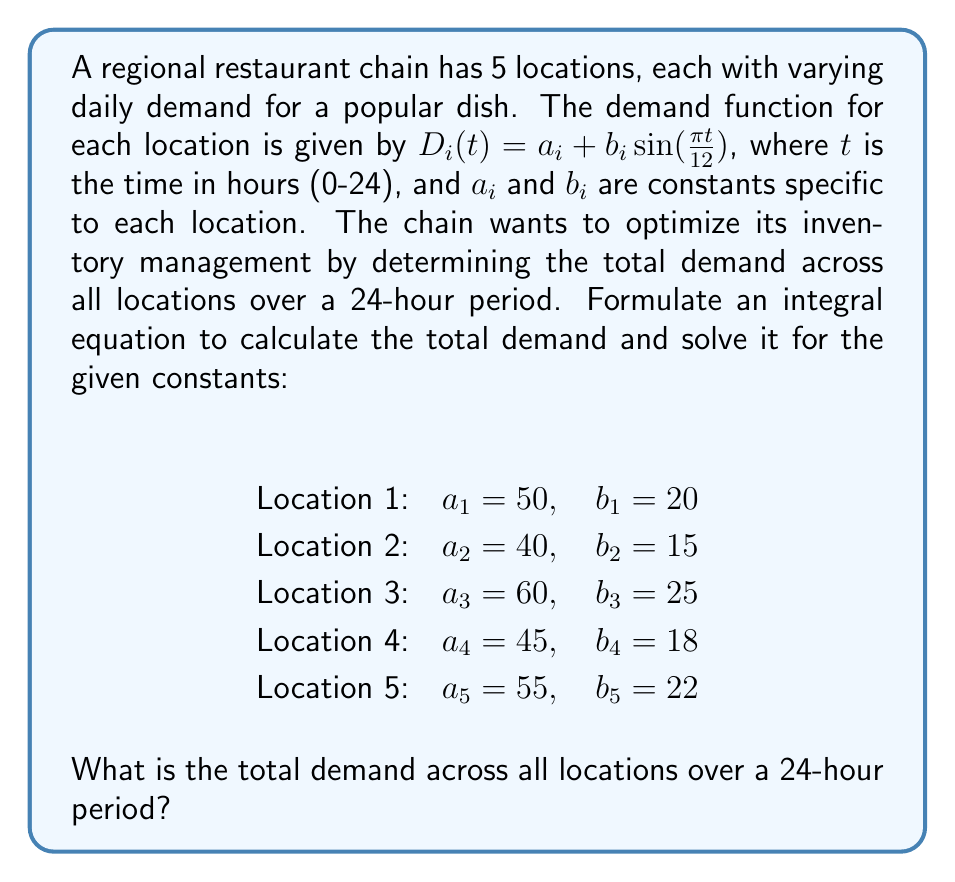Solve this math problem. To solve this problem, we need to follow these steps:

1) First, let's formulate the integral equation for the total demand across all locations over a 24-hour period:

   $$\text{Total Demand} = \sum_{i=1}^{5} \int_{0}^{24} D_i(t) dt$$

2) Substitute the demand function for each location:

   $$\text{Total Demand} = \sum_{i=1}^{5} \int_{0}^{24} (a_i + b_i \sin(\frac{\pi t}{12})) dt$$

3) We can split this into two integrals:

   $$\text{Total Demand} = \sum_{i=1}^{5} [\int_{0}^{24} a_i dt + \int_{0}^{24} b_i \sin(\frac{\pi t}{12}) dt]$$

4) The first integral is straightforward:

   $$\int_{0}^{24} a_i dt = 24a_i$$

5) For the second integral, we use the substitution $u = \frac{\pi t}{12}$, $du = \frac{\pi}{12} dt$:

   $$\int_{0}^{24} b_i \sin(\frac{\pi t}{12}) dt = \frac{12b_i}{\pi} [-\cos(u)]_{0}^{2\pi} = \frac{24b_i}{\pi}$$

6) Therefore, for each location, the demand over 24 hours is:

   $$24a_i + \frac{24b_i}{\pi}$$

7) Now, we sum this for all 5 locations:

   $$\text{Total Demand} = \sum_{i=1}^{5} (24a_i + \frac{24b_i}{\pi})$$

8) Substituting the given values:

   $$\text{Total Demand} = 24(50 + 40 + 60 + 45 + 55) + \frac{24}{\pi}(20 + 15 + 25 + 18 + 22)$$

9) Simplifying:

   $$\text{Total Demand} = 24(250) + \frac{24}{\pi}(100)$$
   $$\text{Total Demand} = 6000 + \frac{2400}{\pi}$$

10) Calculating the final value:

    $$\text{Total Demand} ≈ 6763.66$$
Answer: 6763.66 units 